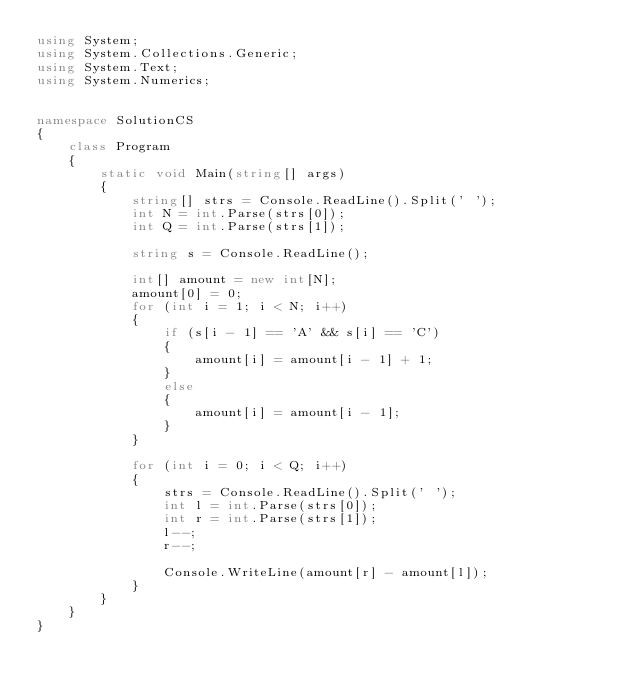<code> <loc_0><loc_0><loc_500><loc_500><_C#_>using System;
using System.Collections.Generic;
using System.Text;
using System.Numerics;


namespace SolutionCS
{
    class Program
    {
        static void Main(string[] args)
        {
            string[] strs = Console.ReadLine().Split(' ');
            int N = int.Parse(strs[0]);
            int Q = int.Parse(strs[1]);

            string s = Console.ReadLine();

            int[] amount = new int[N];
            amount[0] = 0;
            for (int i = 1; i < N; i++)
            {
                if (s[i - 1] == 'A' && s[i] == 'C')
                {
                    amount[i] = amount[i - 1] + 1;
                }
                else
                {
                    amount[i] = amount[i - 1];
                }
            }

            for (int i = 0; i < Q; i++)
            {
                strs = Console.ReadLine().Split(' ');
                int l = int.Parse(strs[0]);
                int r = int.Parse(strs[1]);
                l--;
                r--;

                Console.WriteLine(amount[r] - amount[l]);
            }
        }
    }
}</code> 